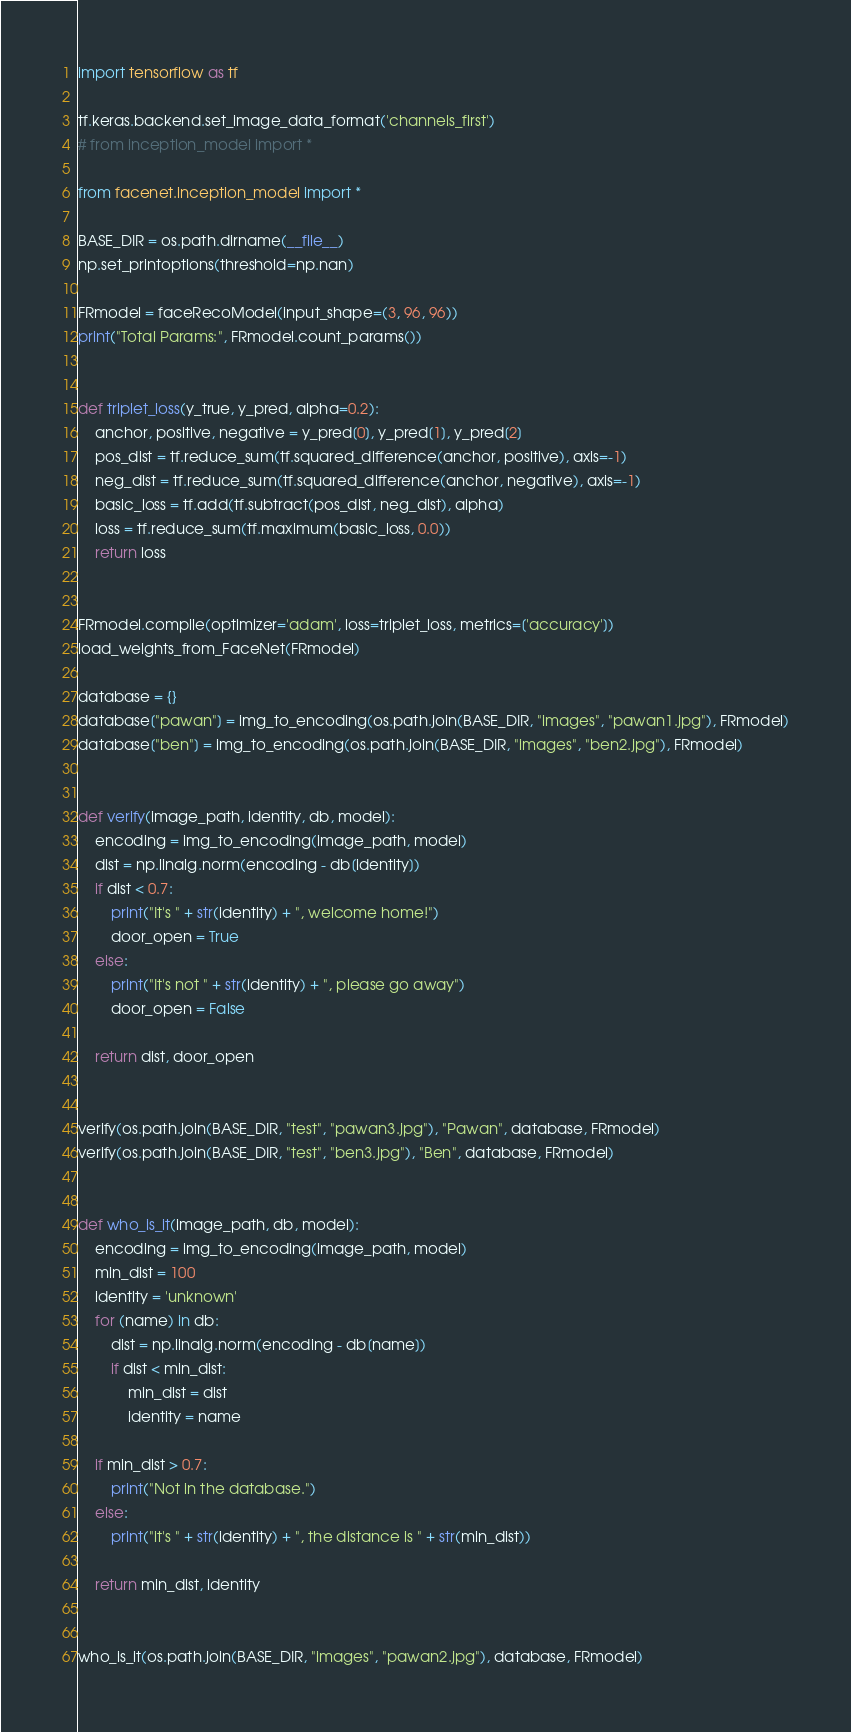Convert code to text. <code><loc_0><loc_0><loc_500><loc_500><_Python_>import tensorflow as tf

tf.keras.backend.set_image_data_format('channels_first')
# from inception_model import *

from facenet.inception_model import *

BASE_DIR = os.path.dirname(__file__)
np.set_printoptions(threshold=np.nan)

FRmodel = faceRecoModel(input_shape=(3, 96, 96))
print("Total Params:", FRmodel.count_params())


def triplet_loss(y_true, y_pred, alpha=0.2):
    anchor, positive, negative = y_pred[0], y_pred[1], y_pred[2]
    pos_dist = tf.reduce_sum(tf.squared_difference(anchor, positive), axis=-1)
    neg_dist = tf.reduce_sum(tf.squared_difference(anchor, negative), axis=-1)
    basic_loss = tf.add(tf.subtract(pos_dist, neg_dist), alpha)
    loss = tf.reduce_sum(tf.maximum(basic_loss, 0.0))
    return loss


FRmodel.compile(optimizer='adam', loss=triplet_loss, metrics=['accuracy'])
load_weights_from_FaceNet(FRmodel)

database = {}
database["pawan"] = img_to_encoding(os.path.join(BASE_DIR, "images", "pawan1.jpg"), FRmodel)
database["ben"] = img_to_encoding(os.path.join(BASE_DIR, "images", "ben2.jpg"), FRmodel)


def verify(image_path, identity, db, model):
    encoding = img_to_encoding(image_path, model)
    dist = np.linalg.norm(encoding - db[identity])
    if dist < 0.7:
        print("It's " + str(identity) + ", welcome home!")
        door_open = True
    else:
        print("It's not " + str(identity) + ", please go away")
        door_open = False

    return dist, door_open


verify(os.path.join(BASE_DIR, "test", "pawan3.jpg"), "Pawan", database, FRmodel)
verify(os.path.join(BASE_DIR, "test", "ben3.jpg"), "Ben", database, FRmodel)


def who_is_it(image_path, db, model):
    encoding = img_to_encoding(image_path, model)
    min_dist = 100
    identity = 'unknown'
    for (name) in db:
        dist = np.linalg.norm(encoding - db[name])
        if dist < min_dist:
            min_dist = dist
            identity = name

    if min_dist > 0.7:
        print("Not in the database.")
    else:
        print("it's " + str(identity) + ", the distance is " + str(min_dist))

    return min_dist, identity


who_is_it(os.path.join(BASE_DIR, "images", "pawan2.jpg"), database, FRmodel)
</code> 